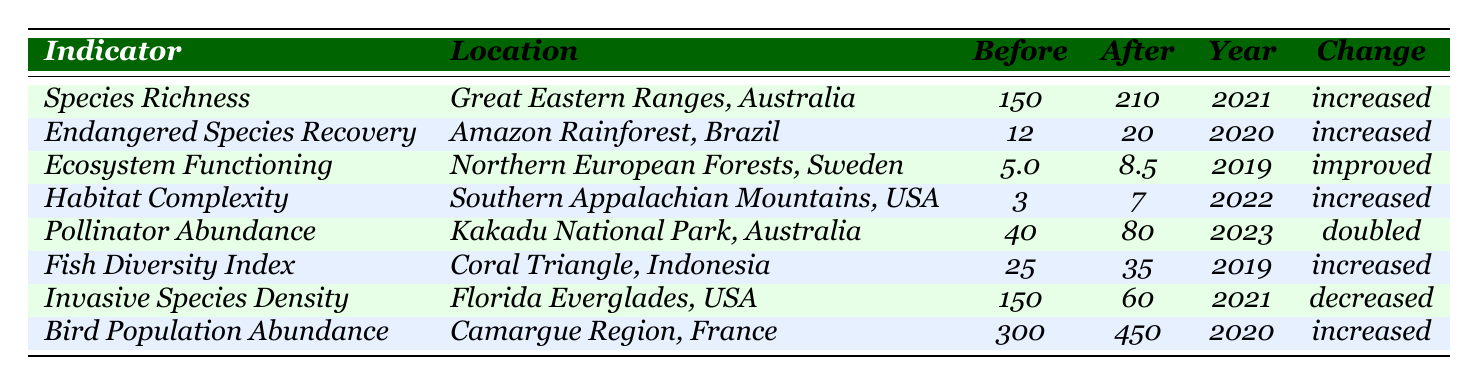What was the species richness before restoration in the Great Eastern Ranges, Australia? The table lists the species richness before restoration in the Great Eastern Ranges as 150.
Answer: 150 By how much did the endangered species recovery increase in the Amazon Rainforest, Brazil? The increase in endangered species recovery is calculated as 20 (after) - 12 (before) = 8.
Answer: 8 What is the change in the fish diversity index in the Coral Triangle, Indonesia? The fish diversity index increased after restoration from 25 to 35, indicating an increase.
Answer: increased Which location experienced the highest increase in pollinator abundance? Comparing values, Kakadu National Park had an increase from 40 to 80, a doubling of values, making it the highest increase.
Answer: Kakadu National Park Was there a decrease in invasive species density in the Florida Everglades? Yes, the invasive species density decreased from 150 before restoration to 60 after restoration, indicating a decrease.
Answer: Yes What is the average before restoration value across all indicators listed? The average is calculated by summing all before values (150 + 12 + 5 + 3 + 40 + 25 + 150 + 300 = 685) and dividing by 8 indicators (685/8 = 85.625).
Answer: 85.625 How many indicators showed an increase after restoration efforts? Out of the 8 indicators, 6 show an increase after restoration (all but invasive species density and one other measurement).
Answer: 6 What was the change in habitat complexity in the Southern Appalachian Mountains, USA? Habitat complexity increased from 3 to 7, indicating an increase of 4.
Answer: increased Does the data suggest a positive outcome from habitat restoration efforts overall? Yes, most indicators showed increases or improvements, supporting the conclusion that habitat restoration efforts had positive outcomes.
Answer: Yes What was the percentage increase in pollinator abundance after restoration in Kakadu National Park? The percentage increase is calculated as ((80 - 40) / 40) * 100 = 100%.
Answer: 100% 